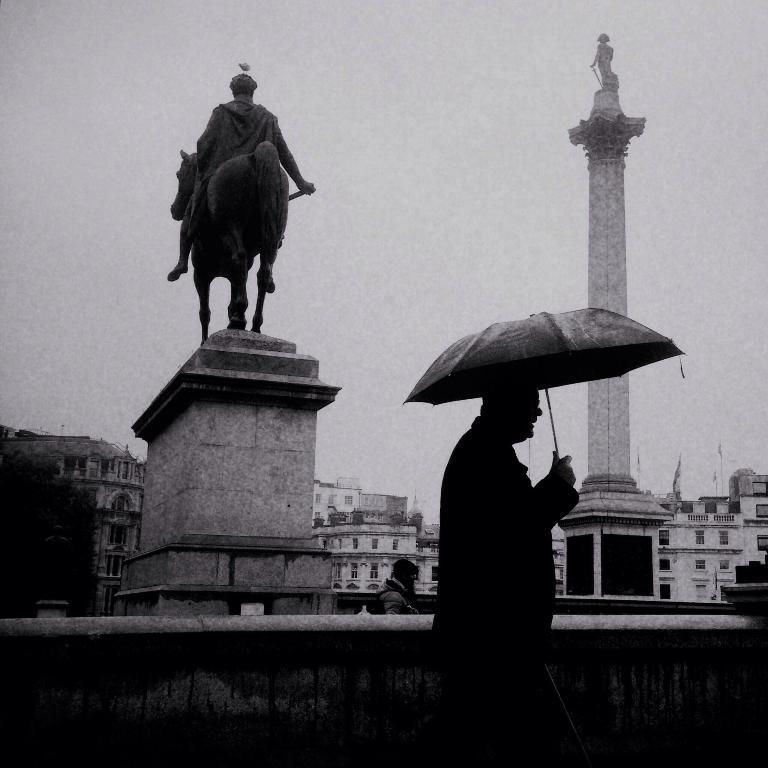What is the main subject of the image? There is a person in the image. What is the person holding in the image? The person is holding an umbrella. What can be seen in the background of the image? The sky is visible in the background of the image. How much money is the person holding in the image? There is no money visible in the image; the person is holding an umbrella. What type of bun is the person eating in the image? There is no bun present in the image; the person is holding an umbrella. 